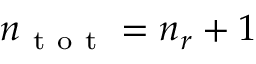Convert formula to latex. <formula><loc_0><loc_0><loc_500><loc_500>n _ { t o t } = n _ { r } + 1</formula> 